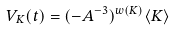<formula> <loc_0><loc_0><loc_500><loc_500>V _ { K } ( t ) = ( - A ^ { - 3 } ) ^ { w ( K ) } \langle K \rangle</formula> 